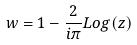<formula> <loc_0><loc_0><loc_500><loc_500>w = 1 - \frac { 2 } { i \pi } L o g ( z )</formula> 